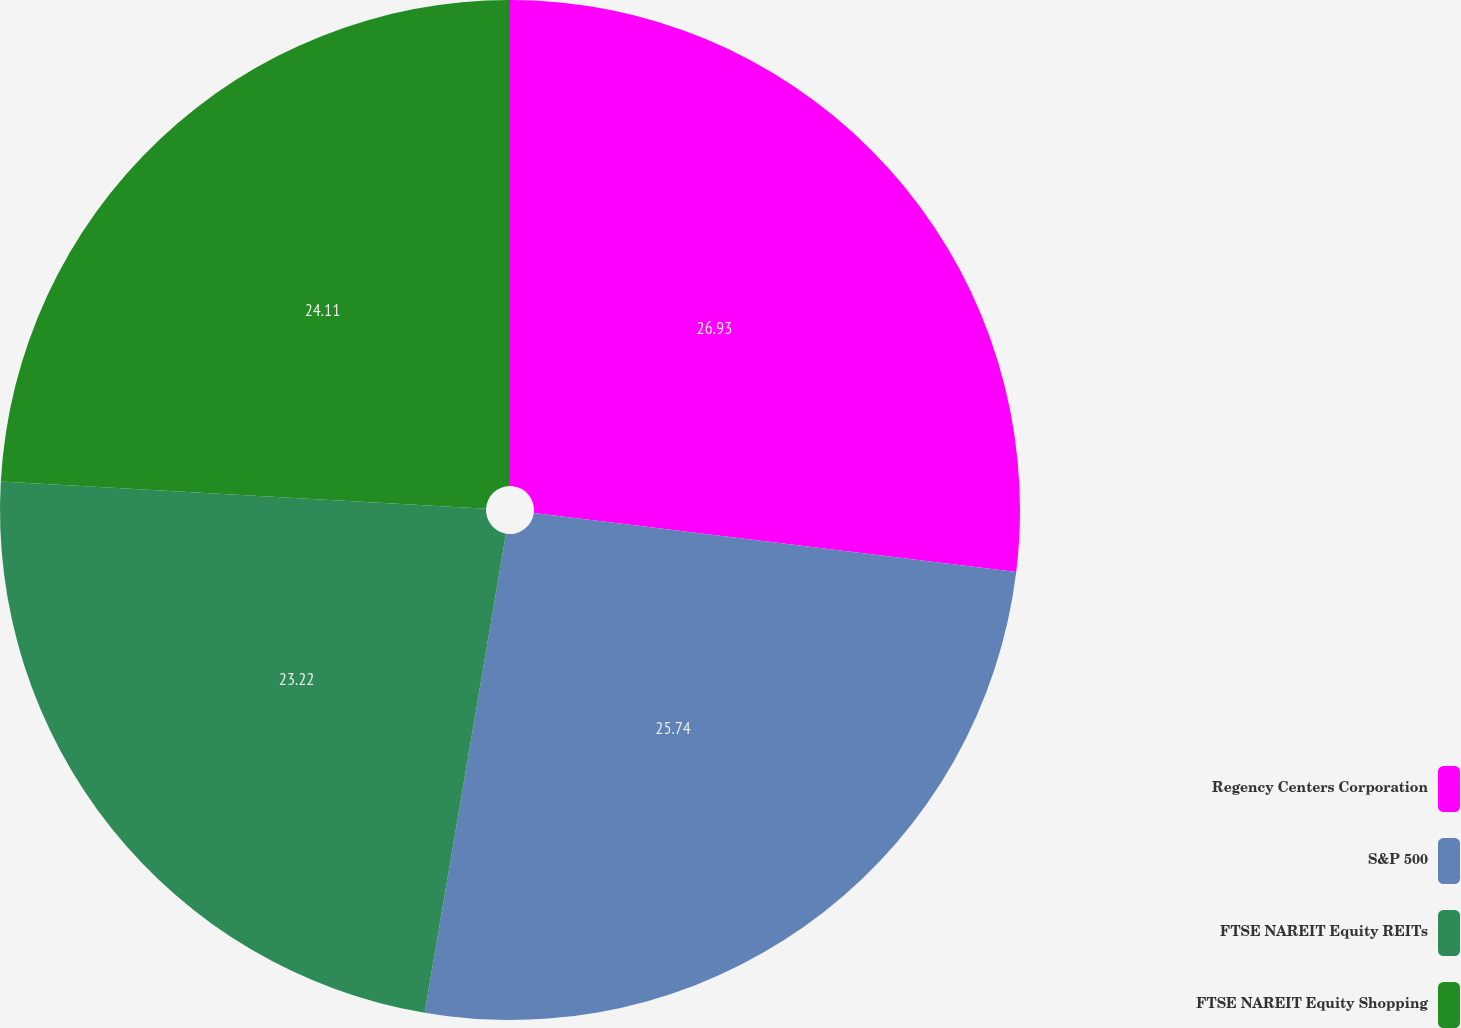<chart> <loc_0><loc_0><loc_500><loc_500><pie_chart><fcel>Regency Centers Corporation<fcel>S&P 500<fcel>FTSE NAREIT Equity REITs<fcel>FTSE NAREIT Equity Shopping<nl><fcel>26.94%<fcel>25.74%<fcel>23.22%<fcel>24.11%<nl></chart> 